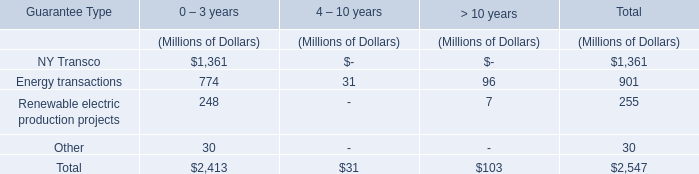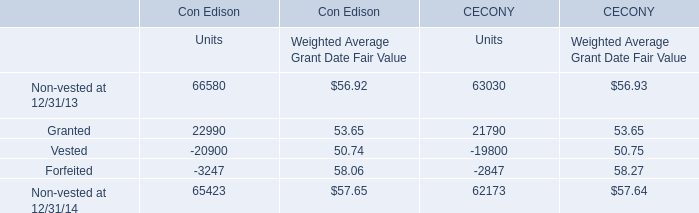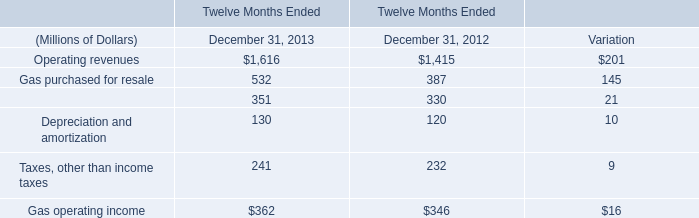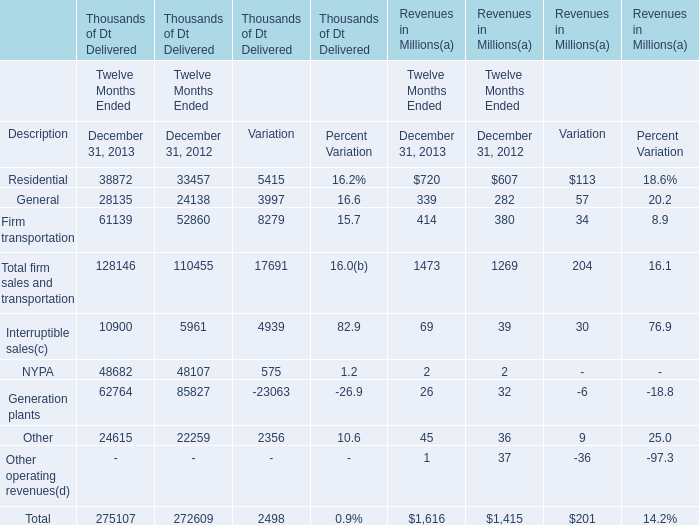What is the total value of Operating revenues, Gas purchased for resale, Other operations and maintenance and Depreciation and amortization in 2013? (in million) 
Computations: (((1616 + 532) + 351) + 130)
Answer: 2629.0. 